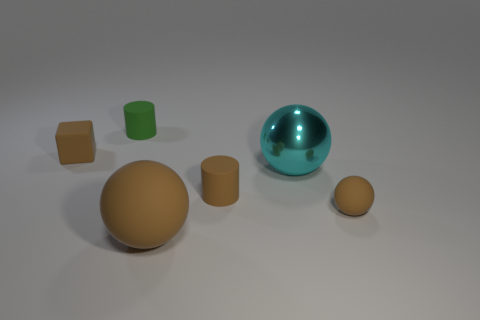Is there anything else that has the same material as the large cyan object?
Offer a terse response. No. There is a small object that is to the left of the object behind the brown block; what number of cyan spheres are to the left of it?
Ensure brevity in your answer.  0. Do the small brown matte object that is to the right of the shiny ball and the big brown thing have the same shape?
Your answer should be compact. Yes. Is there a tiny brown cube that is to the left of the brown matte object behind the small brown cylinder?
Make the answer very short. No. What number of big gray matte cubes are there?
Keep it short and to the point. 0. The matte thing that is to the left of the big cyan object and in front of the small brown matte cylinder is what color?
Provide a succinct answer. Brown. There is another brown thing that is the same shape as the big brown thing; what is its size?
Offer a terse response. Small. What number of metallic things have the same size as the block?
Keep it short and to the point. 0. What material is the tiny green object?
Offer a terse response. Rubber. Are there any rubber cylinders in front of the brown rubber cube?
Provide a succinct answer. Yes. 